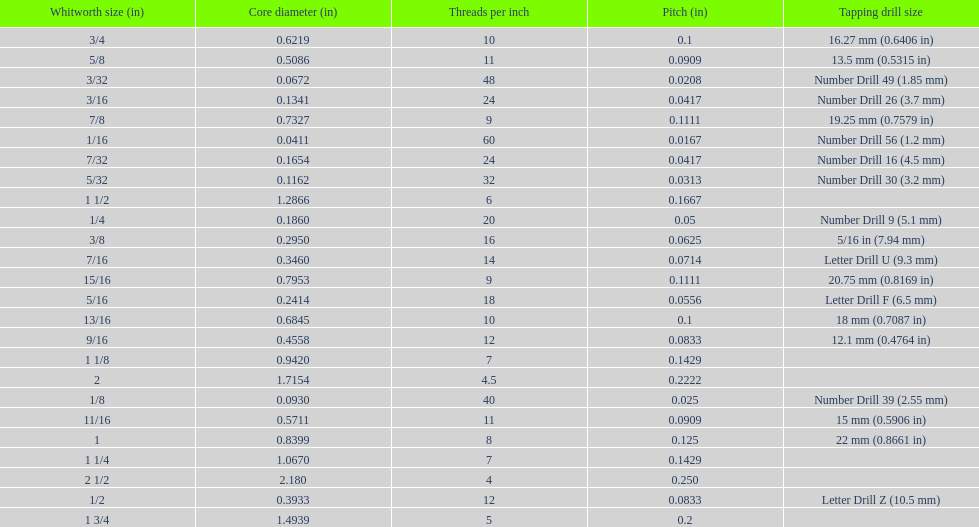What is the core diameter of the last whitworth thread size? 2.180. Parse the full table. {'header': ['Whitworth size (in)', 'Core diameter (in)', 'Threads per\xa0inch', 'Pitch (in)', 'Tapping drill size'], 'rows': [['3/4', '0.6219', '10', '0.1', '16.27\xa0mm (0.6406\xa0in)'], ['5/8', '0.5086', '11', '0.0909', '13.5\xa0mm (0.5315\xa0in)'], ['3/32', '0.0672', '48', '0.0208', 'Number Drill 49 (1.85\xa0mm)'], ['3/16', '0.1341', '24', '0.0417', 'Number Drill 26 (3.7\xa0mm)'], ['7/8', '0.7327', '9', '0.1111', '19.25\xa0mm (0.7579\xa0in)'], ['1/16', '0.0411', '60', '0.0167', 'Number Drill 56 (1.2\xa0mm)'], ['7/32', '0.1654', '24', '0.0417', 'Number Drill 16 (4.5\xa0mm)'], ['5/32', '0.1162', '32', '0.0313', 'Number Drill 30 (3.2\xa0mm)'], ['1 1/2', '1.2866', '6', '0.1667', ''], ['1/4', '0.1860', '20', '0.05', 'Number Drill 9 (5.1\xa0mm)'], ['3/8', '0.2950', '16', '0.0625', '5/16\xa0in (7.94\xa0mm)'], ['7/16', '0.3460', '14', '0.0714', 'Letter Drill U (9.3\xa0mm)'], ['15/16', '0.7953', '9', '0.1111', '20.75\xa0mm (0.8169\xa0in)'], ['5/16', '0.2414', '18', '0.0556', 'Letter Drill F (6.5\xa0mm)'], ['13/16', '0.6845', '10', '0.1', '18\xa0mm (0.7087\xa0in)'], ['9/16', '0.4558', '12', '0.0833', '12.1\xa0mm (0.4764\xa0in)'], ['1 1/8', '0.9420', '7', '0.1429', ''], ['2', '1.7154', '4.5', '0.2222', ''], ['1/8', '0.0930', '40', '0.025', 'Number Drill 39 (2.55\xa0mm)'], ['11/16', '0.5711', '11', '0.0909', '15\xa0mm (0.5906\xa0in)'], ['1', '0.8399', '8', '0.125', '22\xa0mm (0.8661\xa0in)'], ['1 1/4', '1.0670', '7', '0.1429', ''], ['2 1/2', '2.180', '4', '0.250', ''], ['1/2', '0.3933', '12', '0.0833', 'Letter Drill Z (10.5\xa0mm)'], ['1 3/4', '1.4939', '5', '0.2', '']]} 